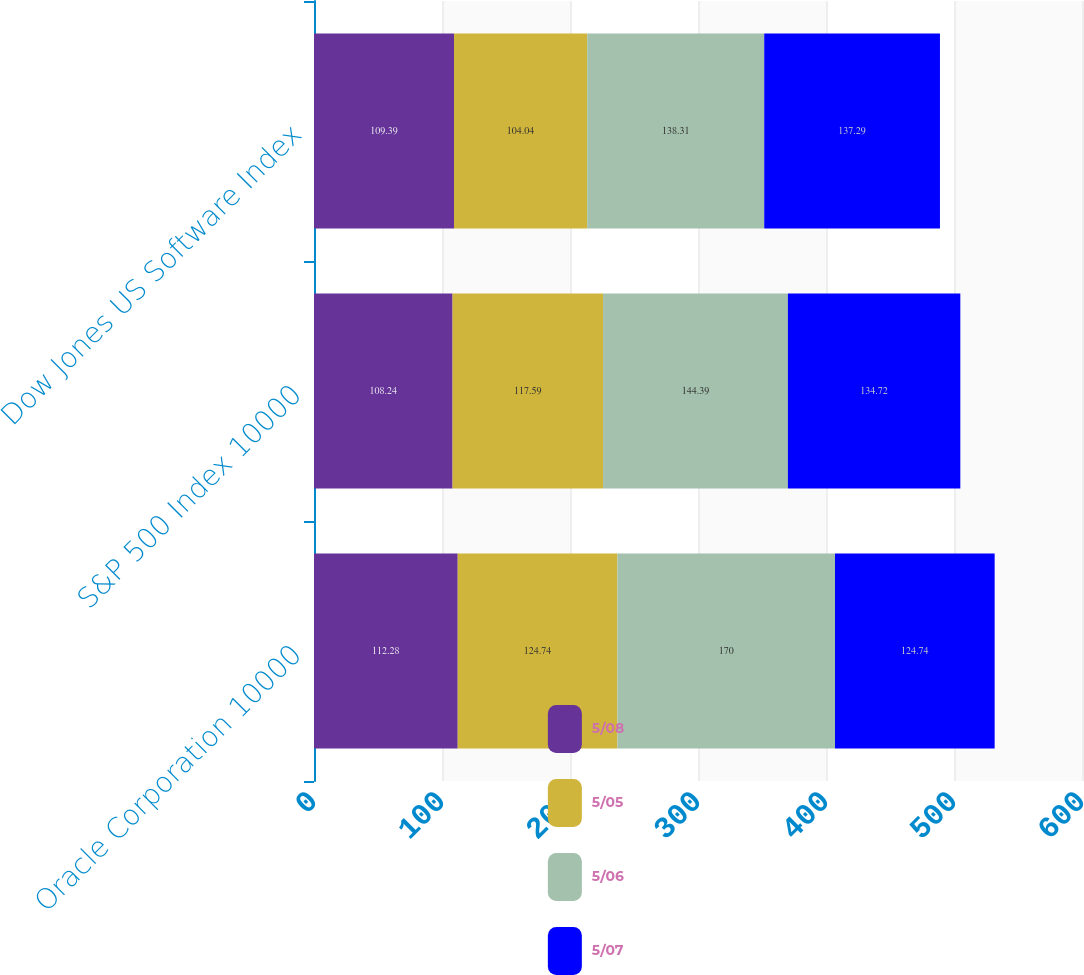<chart> <loc_0><loc_0><loc_500><loc_500><stacked_bar_chart><ecel><fcel>Oracle Corporation 10000<fcel>S&P 500 Index 10000<fcel>Dow Jones US Software Index<nl><fcel>5/08<fcel>112.28<fcel>108.24<fcel>109.39<nl><fcel>5/05<fcel>124.74<fcel>117.59<fcel>104.04<nl><fcel>5/06<fcel>170<fcel>144.39<fcel>138.31<nl><fcel>5/07<fcel>124.74<fcel>134.72<fcel>137.29<nl></chart> 